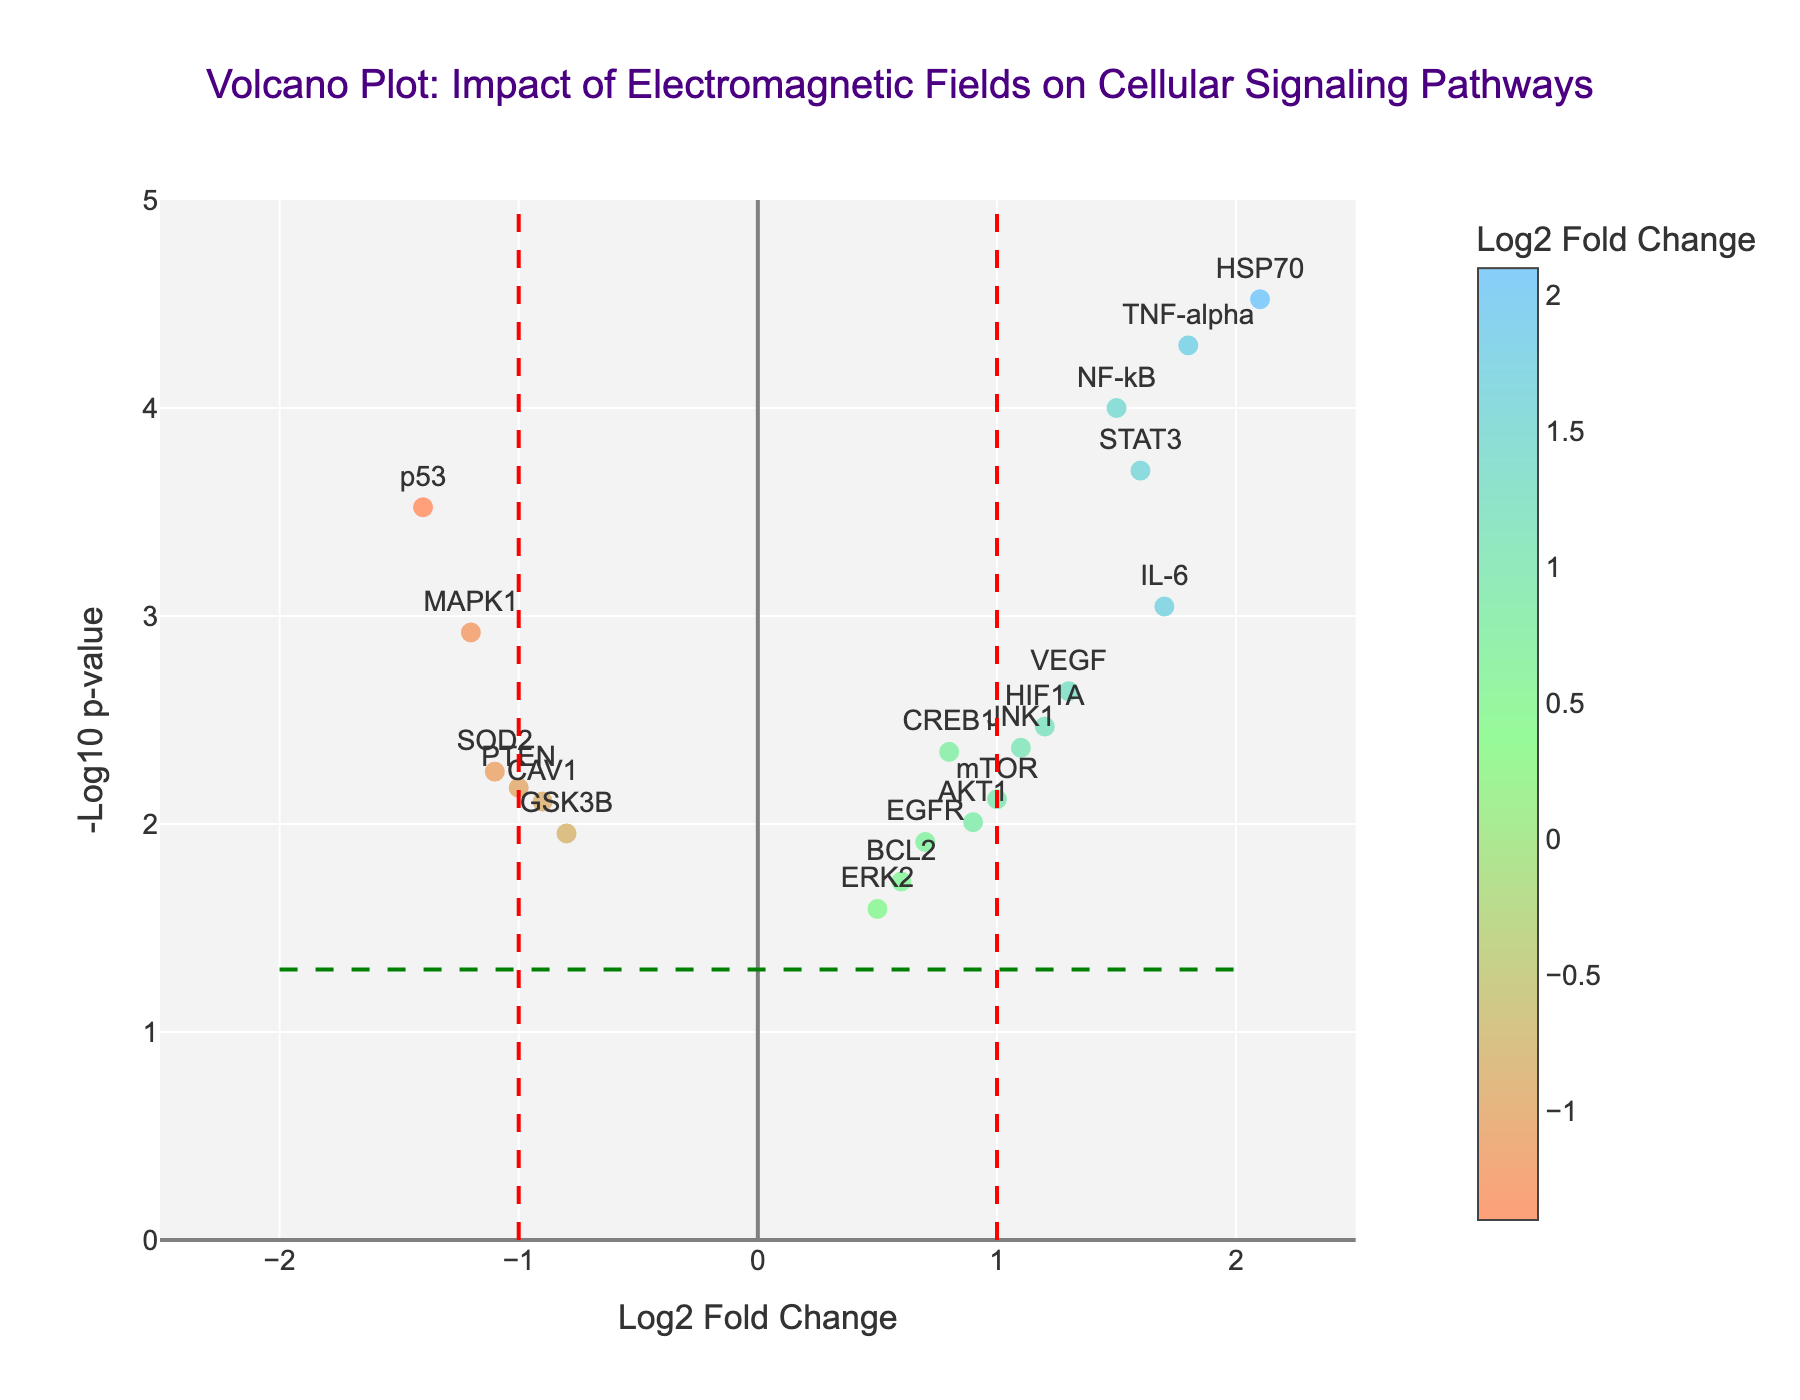What is the title of the plot? The title is displayed at the top of the figure, centered and bold, usually indicating the main topic or focus of the plot.
Answer: Volcano Plot: Impact of Electromagnetic Fields on Cellular Signaling Pathways What does the x-axis represent? The x-axis label is found directly below the horizontal axis and indicates the measure plotted along this axis.
Answer: Log2 Fold Change What does the y-axis represent? The y-axis label is found directly to the left of the vertical axis and indicates the measure plotted along this axis.
Answer: -Log10 p-value How many genes show a statistically significant change (p-value < 0.05)? There is a horizontal green dashed line indicating the p-value threshold of 0.05. Data points above this line represent genes with statistically significant changes.
Answer: 18 Which gene has the highest -log10 p-value? The highest -log10 p-value will be the point farthest up on the y-axis. The hovertext can also help identify the gene with the highest value.
Answer: HSP70 Which genes are significantly upregulated (log2 fold change > 1 and p-value < 0.05)? Look to the top right section of the plot where the log2 fold change is greater than 1 and above the horizontal dashed line. Hovertext can be used to verify the gene names.
Answer: NF-kB, HSP70, VEGF, TNF-alpha, IL-6, STAT3 Which genes are significantly downregulated (log2 fold change < -1 and p-value < 0.05)? Look to the top left section of the plot where the log2 fold change is less than -1 and above the horizontal dashed line. Hovertext can be used to verify the gene names.
Answer: MAPK1, p53 How many genes have a log2 fold change greater than 1? Count the number of data points to the right of the vertical red dashed line at x = 1.
Answer: 7 Which gene has the highest log2 fold change? The highest log2 fold change is identified by the data point farthest to the right on the x-axis. Hovertext can also help verify the gene name.
Answer: HSP70 How do the expressions of MAPK1 and TNF-alpha compare? Compare the x (log2 fold change) and y (-log10 p-value) values for both genes. Refer to the hovertext for precise values if necessary.
Answer: MAPK1 is downregulated with a lower -log10 p-value, while TNF-alpha is upregulated with a higher -log10 p-value (MAPK1: Log2 FC: -1.2, p-value: 0.0012; TNF-alpha: Log2 FC: 1.8, p-value: 0.00005) 